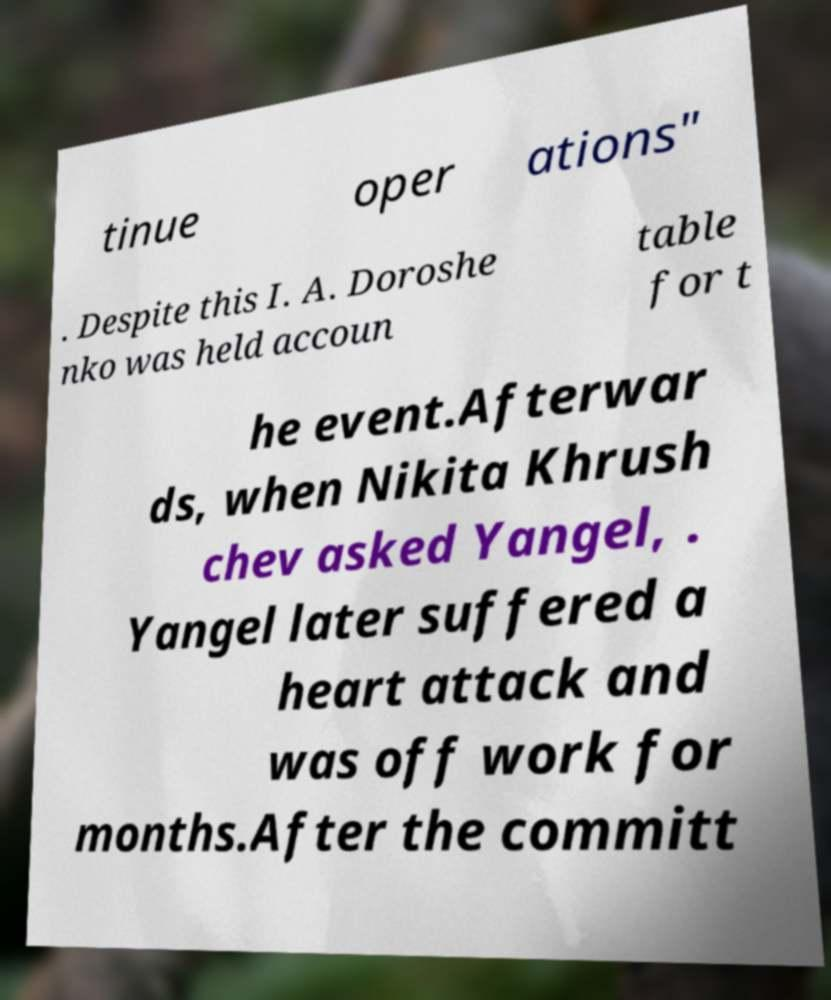Could you extract and type out the text from this image? tinue oper ations" . Despite this I. A. Doroshe nko was held accoun table for t he event.Afterwar ds, when Nikita Khrush chev asked Yangel, . Yangel later suffered a heart attack and was off work for months.After the committ 